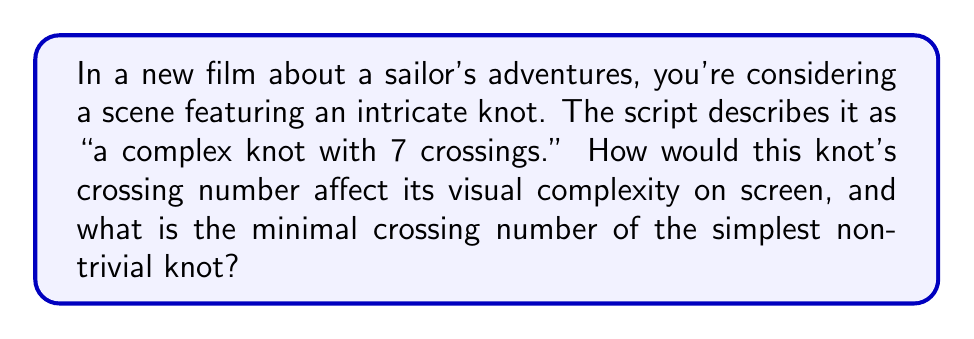Can you solve this math problem? To address this question, let's break it down step-by-step:

1. Crossing number definition:
   The crossing number of a knot is the minimum number of crossings that occur in any projection of the knot onto a plane.

2. Visual complexity:
   A higher crossing number generally indicates a more visually complex knot. In this case, a knot with 7 crossings would appear quite intricate on screen, potentially drawing the viewer's attention.

3. Relation to film:
   For a film studio executive, understanding the visual impact is crucial. A 7-crossing knot would:
   a) Create a visually interesting element in the scene
   b) Potentially symbolize the complexity of the sailor's journey or skills
   c) Require careful prop design and possibly CGI to accurately represent

4. Minimal crossing number of the simplest non-trivial knot:
   The simplest non-trivial knot is the trefoil knot, which has a minimal crossing number of 3.

5. Mathematical representation:
   We can represent the crossing number of a knot $K$ as $c(K)$. For the trefoil knot $T$:

   $$c(T) = 3$$

6. Visual representation:
   A simple diagram of a trefoil knot can be drawn as:

   [asy]
   import geometry;

   path p = (0,0)..(-1,1)..(1,1)..(0,0)..(-1,-1)..(1,-1)..cycle;
   draw(p, linewidth(1));

   dot((0,0));
   dot((-1,1));
   dot((1,1));
   dot((-1,-1));
   dot((1,-1));
   [/asy]

   This diagram shows the minimal 3 crossings of the trefoil knot.
Answer: 3 